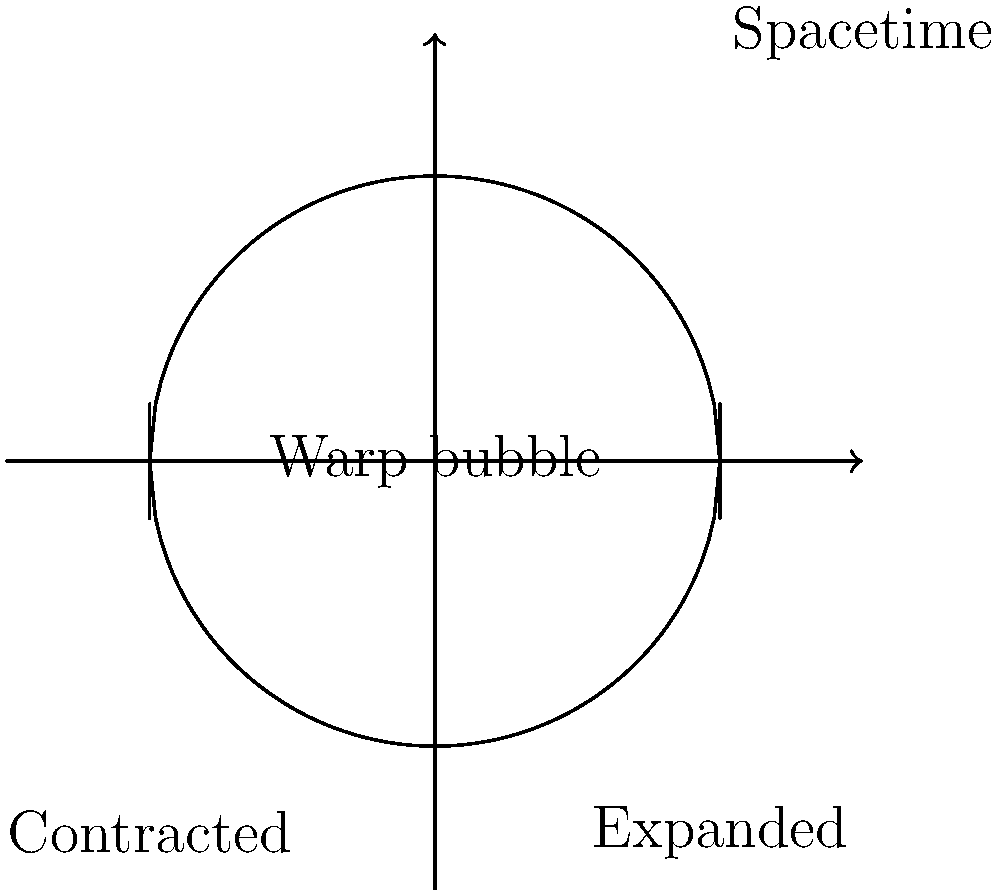In the context of an Alcubierre warp bubble, as illustrated in the 2D diagram, what is the primary function of the regions labeled "Contracted" and "Expanded" in relation to the spacetime fabric? To understand the function of the "Contracted" and "Expanded" regions in an Alcubierre warp bubble, let's break it down step-by-step:

1. The Alcubierre warp drive concept relies on the manipulation of spacetime to achieve faster-than-light travel.

2. The diagram shows a 2D representation of the warp bubble in spacetime.

3. The central region represents the warp bubble, where a spacecraft would theoretically be located.

4. The "Contracted" region (left side of the bubble):
   a. This area represents a compression of spacetime.
   b. Here, the fabric of spacetime is squeezed together.

5. The "Expanded" region (right side of the bubble):
   a. This area represents an expansion of spacetime.
   b. Here, the fabric of spacetime is stretched out.

6. The combination of these effects:
   a. Creates a "wave" in spacetime.
   b. The spacecraft would ride this wave, similar to surfing.

7. As a result:
   a. Space in front of the bubble contracts, bringing the destination closer.
   b. Space behind the bubble expands, pushing the origin farther away.

8. This spacetime distortion allows the bubble (and the spacecraft within it) to effectively move faster than light relative to external observers, without violating local physics within the bubble.

9. The spacecraft itself doesn't move through space in the conventional sense; instead, space moves around the craft.

Therefore, the primary function of these regions is to create a propulsion effect by manipulating the fabric of spacetime, allowing for potential faster-than-light travel without violating special relativity within the bubble.
Answer: To create a propulsion effect by contracting space in front and expanding it behind, enabling potential faster-than-light travel. 